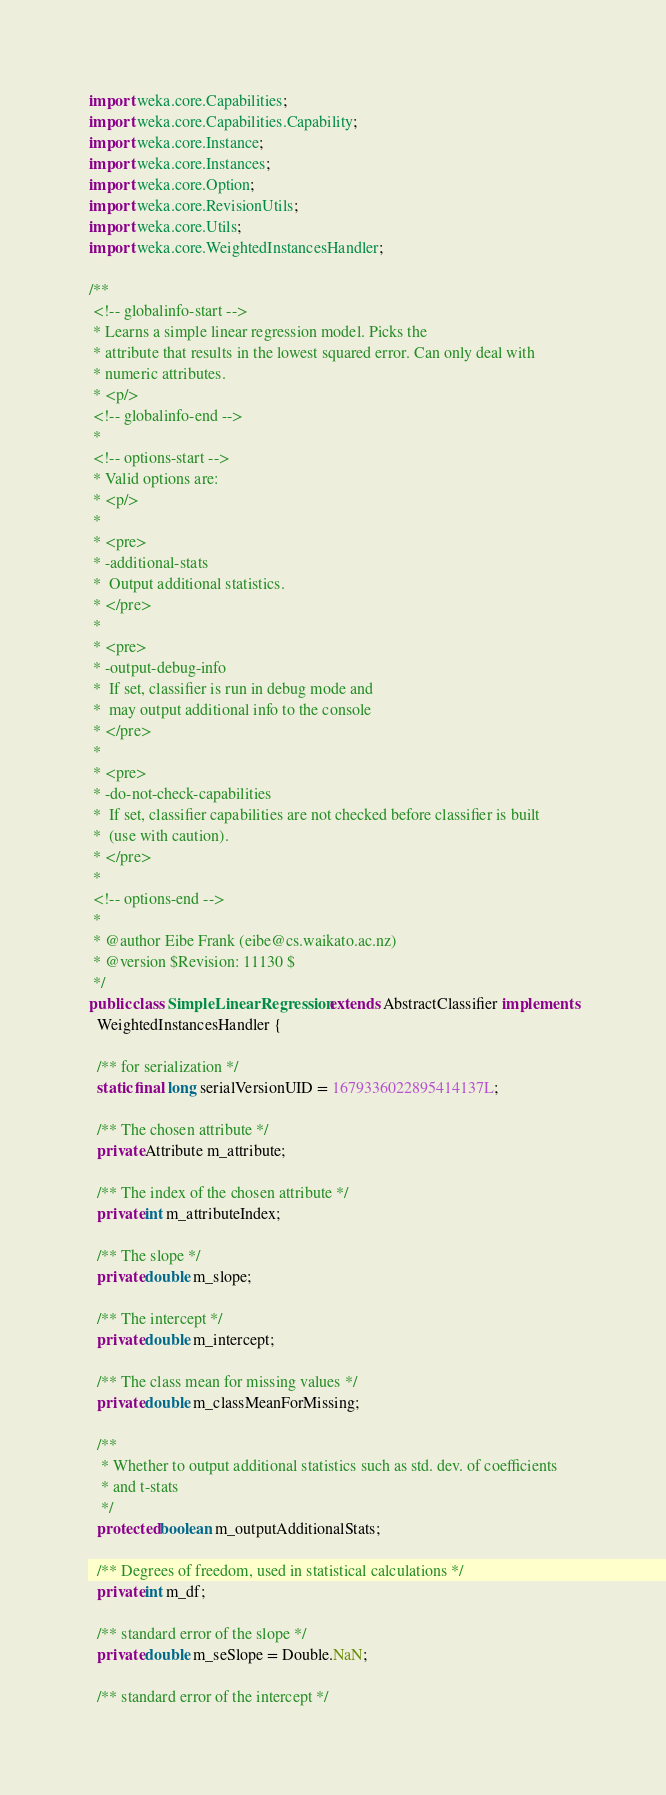Convert code to text. <code><loc_0><loc_0><loc_500><loc_500><_Java_>import weka.core.Capabilities;
import weka.core.Capabilities.Capability;
import weka.core.Instance;
import weka.core.Instances;
import weka.core.Option;
import weka.core.RevisionUtils;
import weka.core.Utils;
import weka.core.WeightedInstancesHandler;

/**
 <!-- globalinfo-start --> 
 * Learns a simple linear regression model. Picks the
 * attribute that results in the lowest squared error. Can only deal with
 * numeric attributes.
 * <p/>
 <!-- globalinfo-end -->
 * 
 <!-- options-start --> 
 * Valid options are:
 * <p/>
 * 
 * <pre>
 * -additional-stats
 *  Output additional statistics.
 * </pre>
 * 
 * <pre>
 * -output-debug-info
 *  If set, classifier is run in debug mode and
 *  may output additional info to the console
 * </pre>
 * 
 * <pre>
 * -do-not-check-capabilities
 *  If set, classifier capabilities are not checked before classifier is built
 *  (use with caution).
 * </pre>
 * 
 <!-- options-end -->
 * 
 * @author Eibe Frank (eibe@cs.waikato.ac.nz)
 * @version $Revision: 11130 $
 */
public class SimpleLinearRegression extends AbstractClassifier implements
  WeightedInstancesHandler {

  /** for serialization */
  static final long serialVersionUID = 1679336022895414137L;

  /** The chosen attribute */
  private Attribute m_attribute;

  /** The index of the chosen attribute */
  private int m_attributeIndex;

  /** The slope */
  private double m_slope;

  /** The intercept */
  private double m_intercept;

  /** The class mean for missing values */
  private double m_classMeanForMissing;

  /**
   * Whether to output additional statistics such as std. dev. of coefficients
   * and t-stats
   */
  protected boolean m_outputAdditionalStats;

  /** Degrees of freedom, used in statistical calculations */
  private int m_df;

  /** standard error of the slope */
  private double m_seSlope = Double.NaN;

  /** standard error of the intercept */</code> 